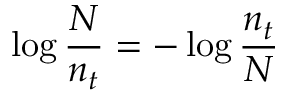<formula> <loc_0><loc_0><loc_500><loc_500>\log { \frac { N } { n _ { t } } } = - \log { \frac { n _ { t } } { N } }</formula> 